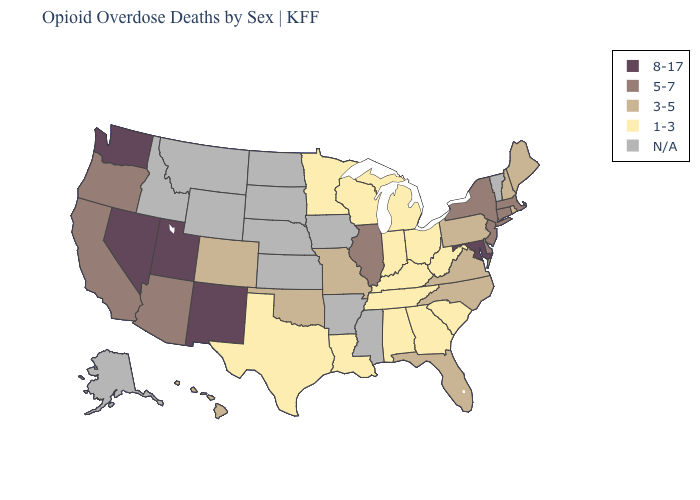Among the states that border Mississippi , which have the highest value?
Be succinct. Alabama, Louisiana, Tennessee. What is the value of Vermont?
Give a very brief answer. N/A. Among the states that border Tennessee , which have the lowest value?
Short answer required. Alabama, Georgia, Kentucky. Among the states that border Kansas , which have the highest value?
Short answer required. Colorado, Missouri, Oklahoma. What is the lowest value in the MidWest?
Give a very brief answer. 1-3. What is the lowest value in the USA?
Give a very brief answer. 1-3. What is the lowest value in states that border Michigan?
Concise answer only. 1-3. Which states have the lowest value in the USA?
Quick response, please. Alabama, Georgia, Indiana, Kentucky, Louisiana, Michigan, Minnesota, Ohio, South Carolina, Tennessee, Texas, West Virginia, Wisconsin. Name the states that have a value in the range 1-3?
Give a very brief answer. Alabama, Georgia, Indiana, Kentucky, Louisiana, Michigan, Minnesota, Ohio, South Carolina, Tennessee, Texas, West Virginia, Wisconsin. Does New York have the lowest value in the Northeast?
Short answer required. No. What is the highest value in the West ?
Quick response, please. 8-17. Name the states that have a value in the range 8-17?
Keep it brief. Maryland, Nevada, New Mexico, Utah, Washington. What is the value of Florida?
Keep it brief. 3-5. What is the highest value in states that border Maine?
Give a very brief answer. 3-5. Name the states that have a value in the range N/A?
Write a very short answer. Alaska, Arkansas, Idaho, Iowa, Kansas, Mississippi, Montana, Nebraska, North Dakota, South Dakota, Vermont, Wyoming. 